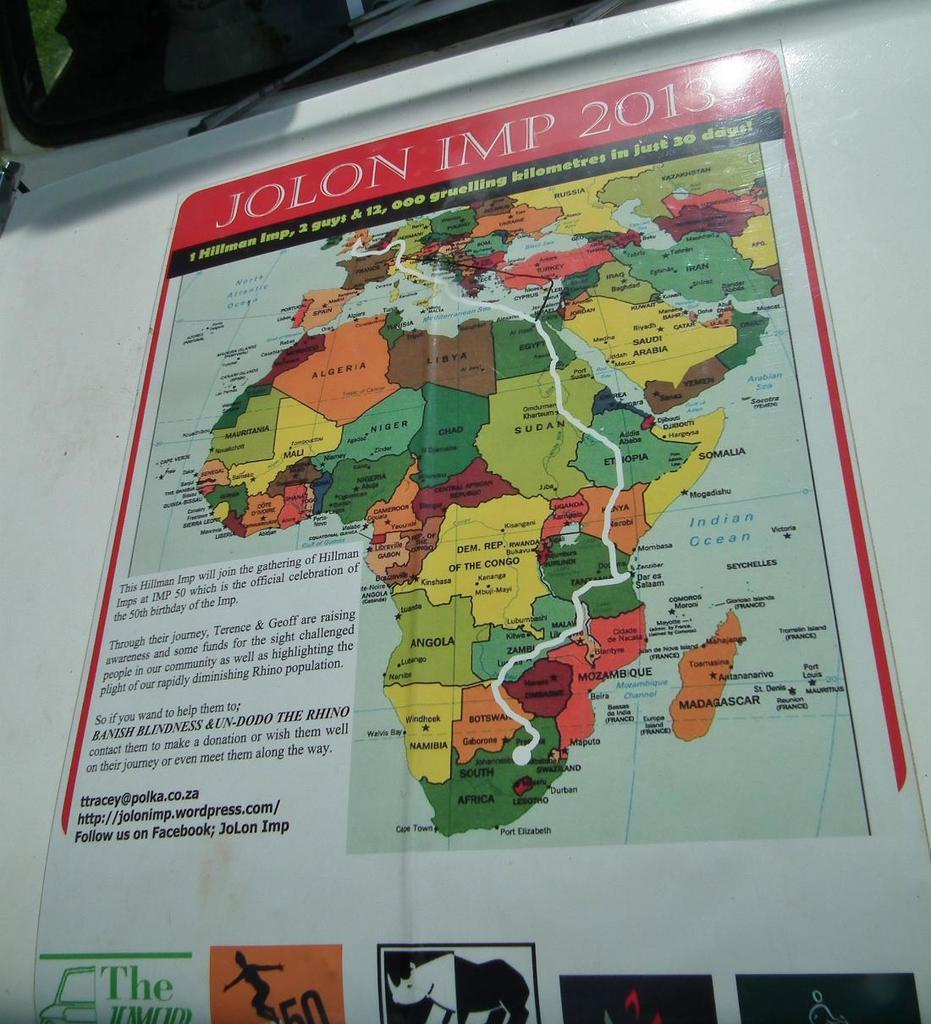<image>
Relay a brief, clear account of the picture shown. A poster of Africa says "JOLON IMP 2013" at the top. 